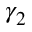Convert formula to latex. <formula><loc_0><loc_0><loc_500><loc_500>\gamma _ { 2 }</formula> 